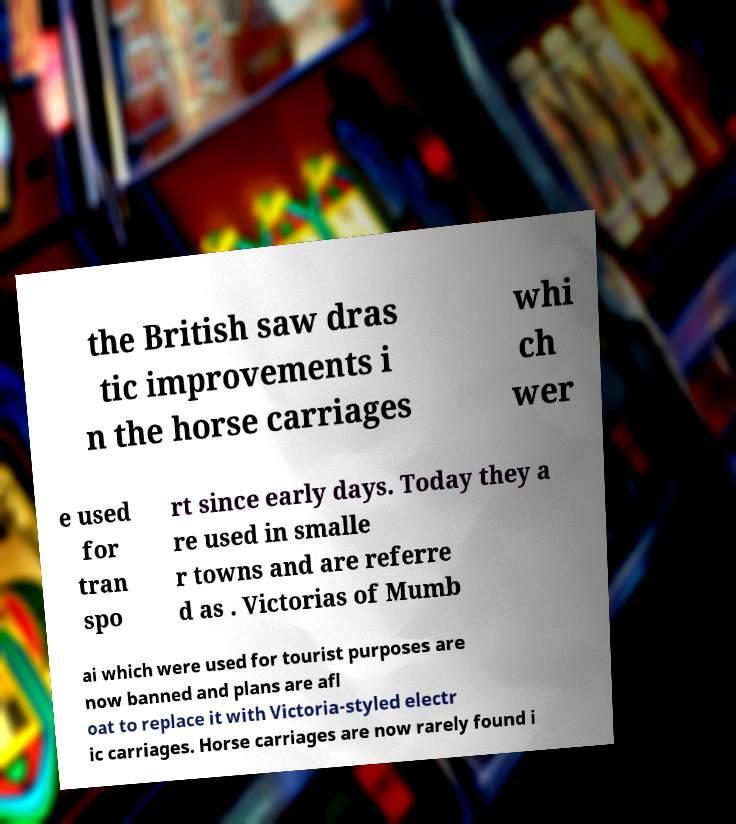What messages or text are displayed in this image? I need them in a readable, typed format. the British saw dras tic improvements i n the horse carriages whi ch wer e used for tran spo rt since early days. Today they a re used in smalle r towns and are referre d as . Victorias of Mumb ai which were used for tourist purposes are now banned and plans are afl oat to replace it with Victoria-styled electr ic carriages. Horse carriages are now rarely found i 